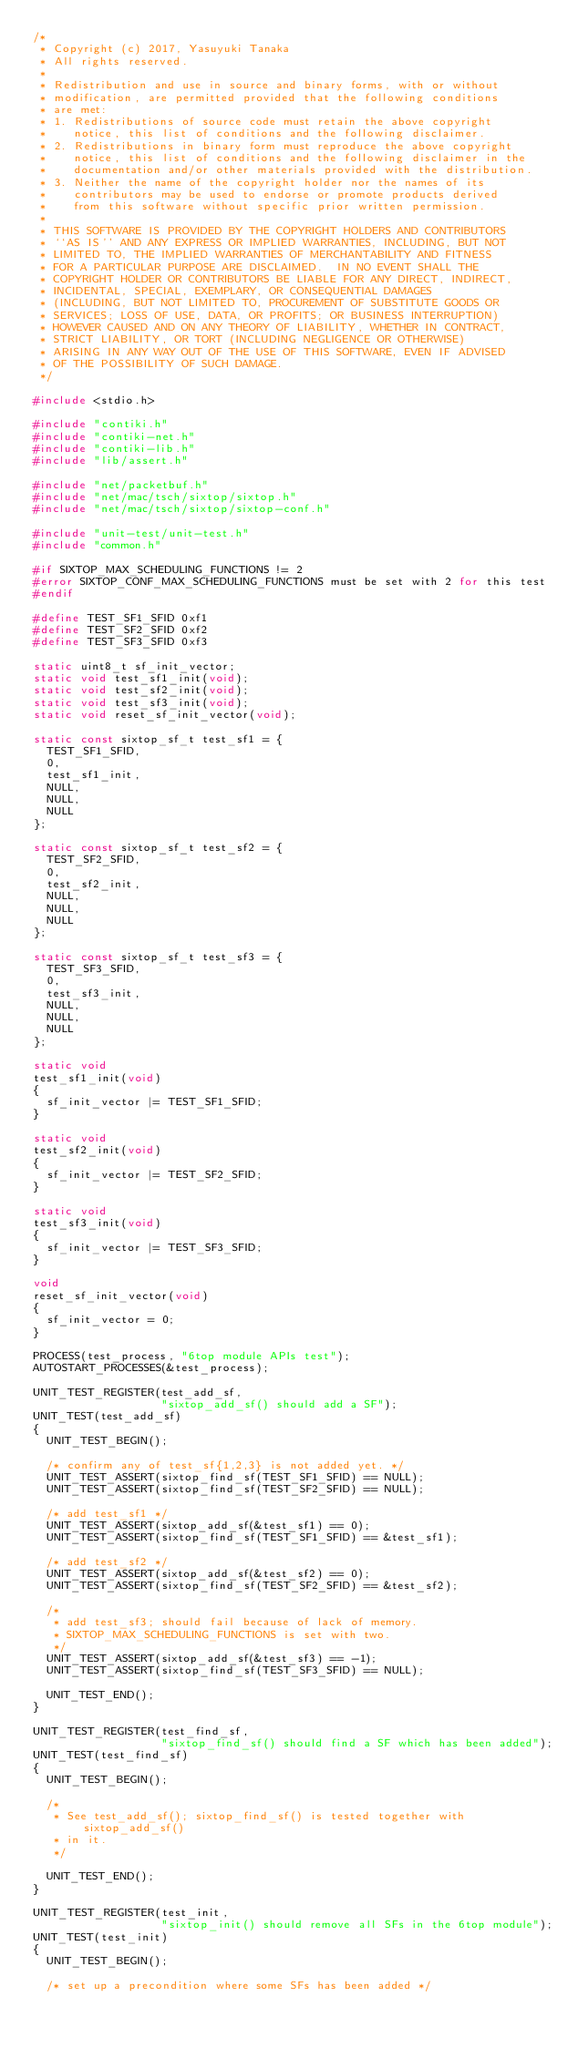Convert code to text. <code><loc_0><loc_0><loc_500><loc_500><_C_>/*
 * Copyright (c) 2017, Yasuyuki Tanaka
 * All rights reserved.
 *
 * Redistribution and use in source and binary forms, with or without
 * modification, are permitted provided that the following conditions
 * are met:
 * 1. Redistributions of source code must retain the above copyright
 *    notice, this list of conditions and the following disclaimer.
 * 2. Redistributions in binary form must reproduce the above copyright
 *    notice, this list of conditions and the following disclaimer in the
 *    documentation and/or other materials provided with the distribution.
 * 3. Neither the name of the copyright holder nor the names of its
 *    contributors may be used to endorse or promote products derived
 *    from this software without specific prior written permission.
 *
 * THIS SOFTWARE IS PROVIDED BY THE COPYRIGHT HOLDERS AND CONTRIBUTORS
 * ``AS IS'' AND ANY EXPRESS OR IMPLIED WARRANTIES, INCLUDING, BUT NOT
 * LIMITED TO, THE IMPLIED WARRANTIES OF MERCHANTABILITY AND FITNESS
 * FOR A PARTICULAR PURPOSE ARE DISCLAIMED.  IN NO EVENT SHALL THE
 * COPYRIGHT HOLDER OR CONTRIBUTORS BE LIABLE FOR ANY DIRECT, INDIRECT,
 * INCIDENTAL, SPECIAL, EXEMPLARY, OR CONSEQUENTIAL DAMAGES
 * (INCLUDING, BUT NOT LIMITED TO, PROCUREMENT OF SUBSTITUTE GOODS OR
 * SERVICES; LOSS OF USE, DATA, OR PROFITS; OR BUSINESS INTERRUPTION)
 * HOWEVER CAUSED AND ON ANY THEORY OF LIABILITY, WHETHER IN CONTRACT,
 * STRICT LIABILITY, OR TORT (INCLUDING NEGLIGENCE OR OTHERWISE)
 * ARISING IN ANY WAY OUT OF THE USE OF THIS SOFTWARE, EVEN IF ADVISED
 * OF THE POSSIBILITY OF SUCH DAMAGE.
 */

#include <stdio.h>

#include "contiki.h"
#include "contiki-net.h"
#include "contiki-lib.h"
#include "lib/assert.h"

#include "net/packetbuf.h"
#include "net/mac/tsch/sixtop/sixtop.h"
#include "net/mac/tsch/sixtop/sixtop-conf.h"

#include "unit-test/unit-test.h"
#include "common.h"

#if SIXTOP_MAX_SCHEDULING_FUNCTIONS != 2
#error SIXTOP_CONF_MAX_SCHEDULING_FUNCTIONS must be set with 2 for this test
#endif

#define TEST_SF1_SFID 0xf1
#define TEST_SF2_SFID 0xf2
#define TEST_SF3_SFID 0xf3

static uint8_t sf_init_vector;
static void test_sf1_init(void);
static void test_sf2_init(void);
static void test_sf3_init(void);
static void reset_sf_init_vector(void);

static const sixtop_sf_t test_sf1 = {
  TEST_SF1_SFID,
  0,
  test_sf1_init,
  NULL,
  NULL,
  NULL
};

static const sixtop_sf_t test_sf2 = {
  TEST_SF2_SFID,
  0,
  test_sf2_init,
  NULL,
  NULL,
  NULL
};

static const sixtop_sf_t test_sf3 = {
  TEST_SF3_SFID,
  0,
  test_sf3_init,
  NULL,
  NULL,
  NULL
};

static void
test_sf1_init(void)
{
  sf_init_vector |= TEST_SF1_SFID;
}

static void
test_sf2_init(void)
{
  sf_init_vector |= TEST_SF2_SFID;
}

static void
test_sf3_init(void)
{
  sf_init_vector |= TEST_SF3_SFID;
}

void
reset_sf_init_vector(void)
{
  sf_init_vector = 0;
}

PROCESS(test_process, "6top module APIs test");
AUTOSTART_PROCESSES(&test_process);

UNIT_TEST_REGISTER(test_add_sf,
                   "sixtop_add_sf() should add a SF");
UNIT_TEST(test_add_sf)
{
  UNIT_TEST_BEGIN();

  /* confirm any of test_sf{1,2,3} is not added yet. */
  UNIT_TEST_ASSERT(sixtop_find_sf(TEST_SF1_SFID) == NULL);
  UNIT_TEST_ASSERT(sixtop_find_sf(TEST_SF2_SFID) == NULL);

  /* add test_sf1 */
  UNIT_TEST_ASSERT(sixtop_add_sf(&test_sf1) == 0);
  UNIT_TEST_ASSERT(sixtop_find_sf(TEST_SF1_SFID) == &test_sf1);

  /* add test_sf2 */
  UNIT_TEST_ASSERT(sixtop_add_sf(&test_sf2) == 0);
  UNIT_TEST_ASSERT(sixtop_find_sf(TEST_SF2_SFID) == &test_sf2);

  /*
   * add test_sf3; should fail because of lack of memory.
   * SIXTOP_MAX_SCHEDULING_FUNCTIONS is set with two.
   */
  UNIT_TEST_ASSERT(sixtop_add_sf(&test_sf3) == -1);
  UNIT_TEST_ASSERT(sixtop_find_sf(TEST_SF3_SFID) == NULL);

  UNIT_TEST_END();
}

UNIT_TEST_REGISTER(test_find_sf,
                   "sixtop_find_sf() should find a SF which has been added");
UNIT_TEST(test_find_sf)
{
  UNIT_TEST_BEGIN();

  /*
   * See test_add_sf(); sixtop_find_sf() is tested together with sixtop_add_sf()
   * in it.
   */

  UNIT_TEST_END();
}

UNIT_TEST_REGISTER(test_init,
                   "sixtop_init() should remove all SFs in the 6top module");
UNIT_TEST(test_init)
{
  UNIT_TEST_BEGIN();

  /* set up a precondition where some SFs has been added */</code> 